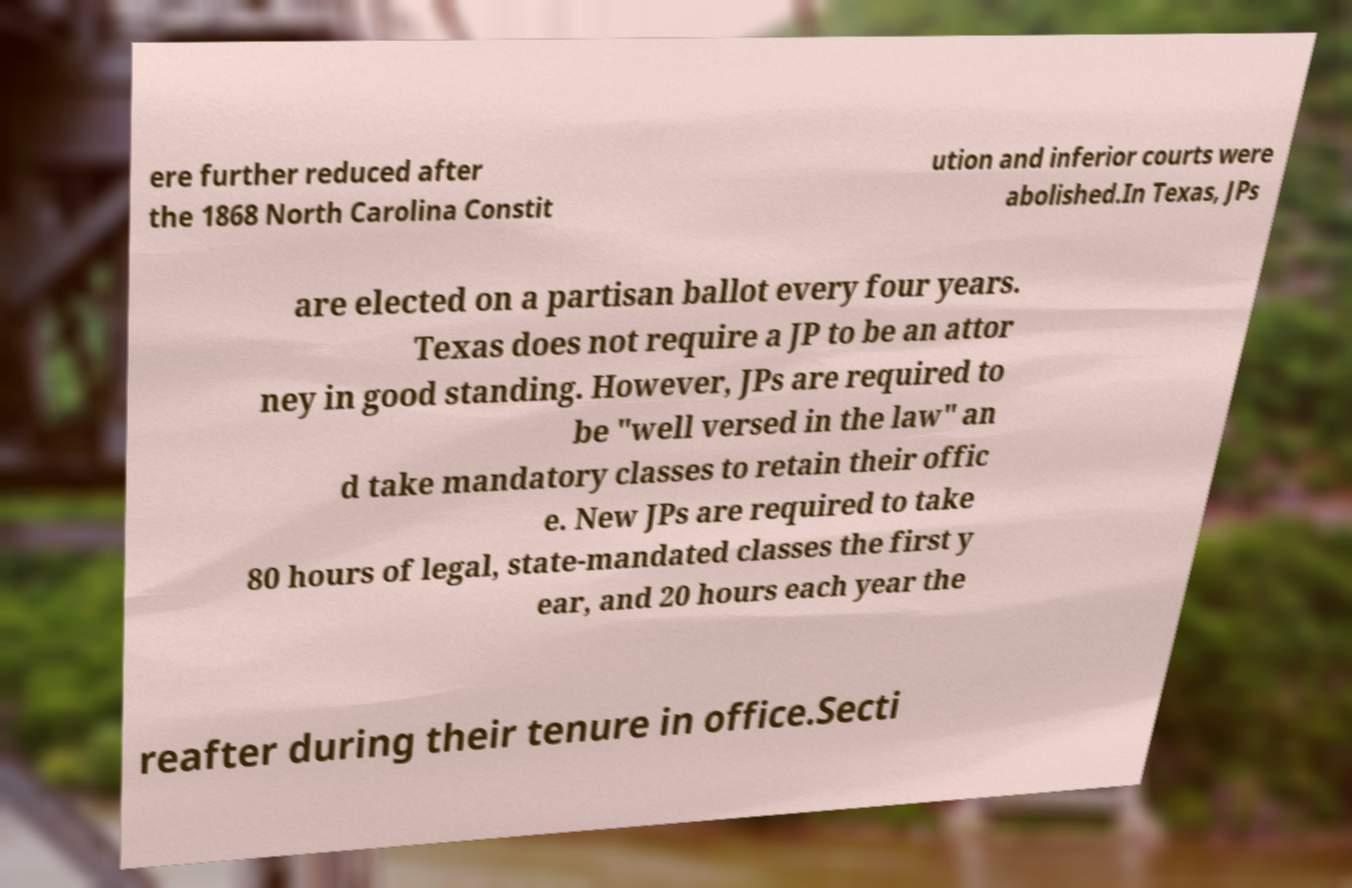Can you accurately transcribe the text from the provided image for me? ere further reduced after the 1868 North Carolina Constit ution and inferior courts were abolished.In Texas, JPs are elected on a partisan ballot every four years. Texas does not require a JP to be an attor ney in good standing. However, JPs are required to be "well versed in the law" an d take mandatory classes to retain their offic e. New JPs are required to take 80 hours of legal, state-mandated classes the first y ear, and 20 hours each year the reafter during their tenure in office.Secti 